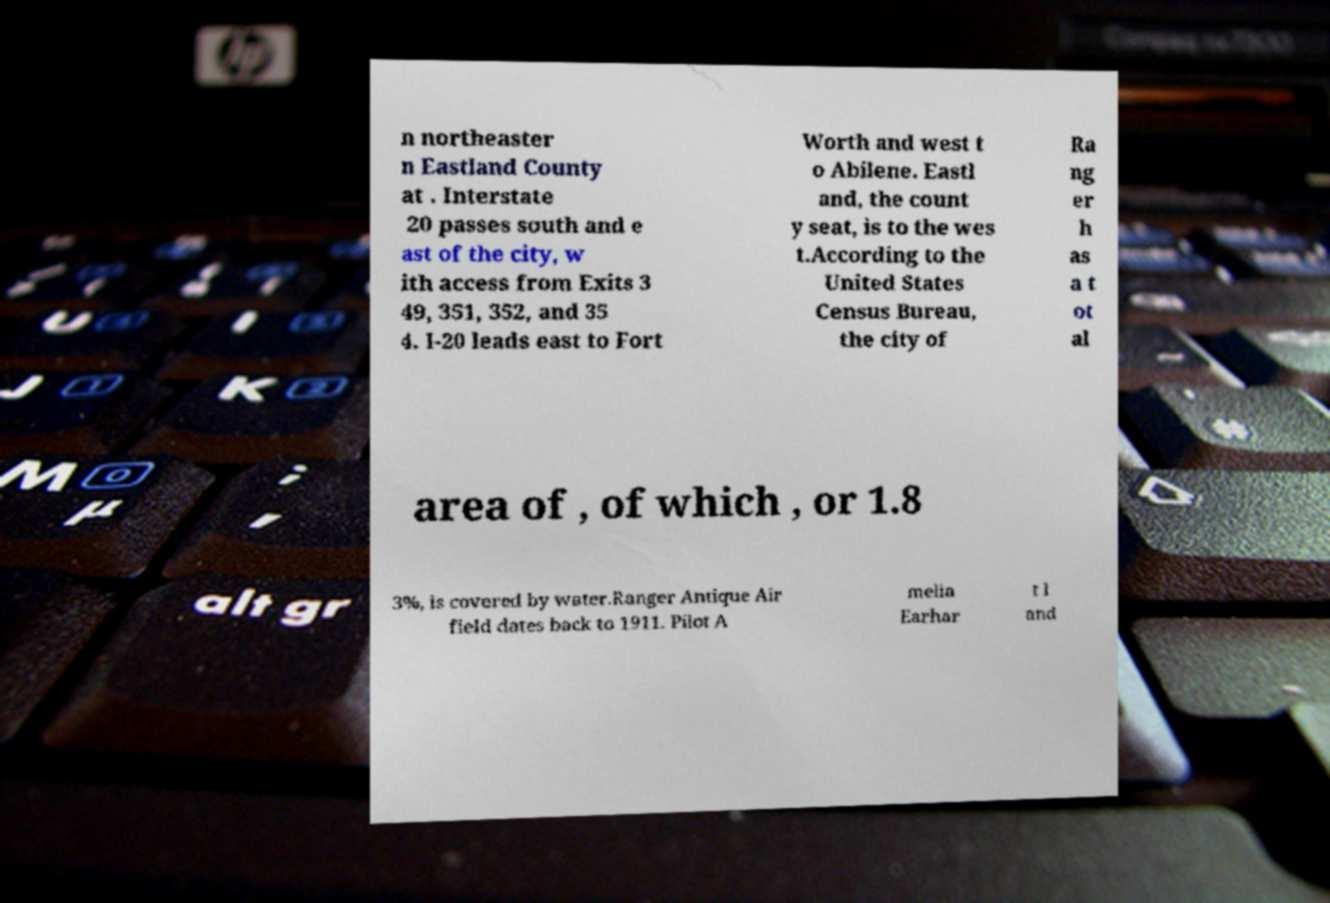Please read and relay the text visible in this image. What does it say? n northeaster n Eastland County at . Interstate 20 passes south and e ast of the city, w ith access from Exits 3 49, 351, 352, and 35 4. I-20 leads east to Fort Worth and west t o Abilene. Eastl and, the count y seat, is to the wes t.According to the United States Census Bureau, the city of Ra ng er h as a t ot al area of , of which , or 1.8 3%, is covered by water.Ranger Antique Air field dates back to 1911. Pilot A melia Earhar t l and 